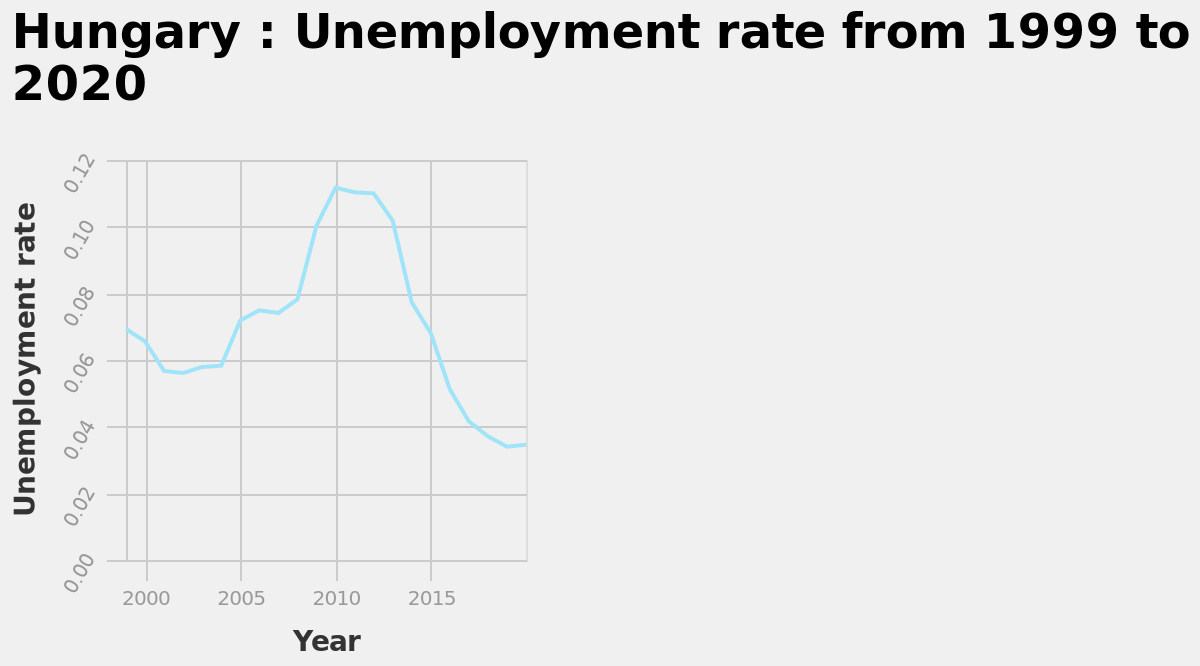<image>
Offer a thorough analysis of the image. Unemployment rates in Hungary dropped from 0.007 to 0.06 from 1999 to 2000 they then levelled until 2004 where they increased steadily until 2010 when they reached a high of 0.11 and from 2010 to 2020 they decreased overall year on year to a new low no of 0.03. 